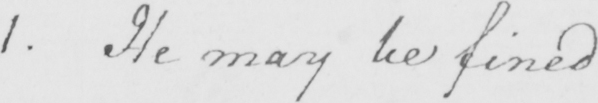What text is written in this handwritten line? 1 . He may be fined 